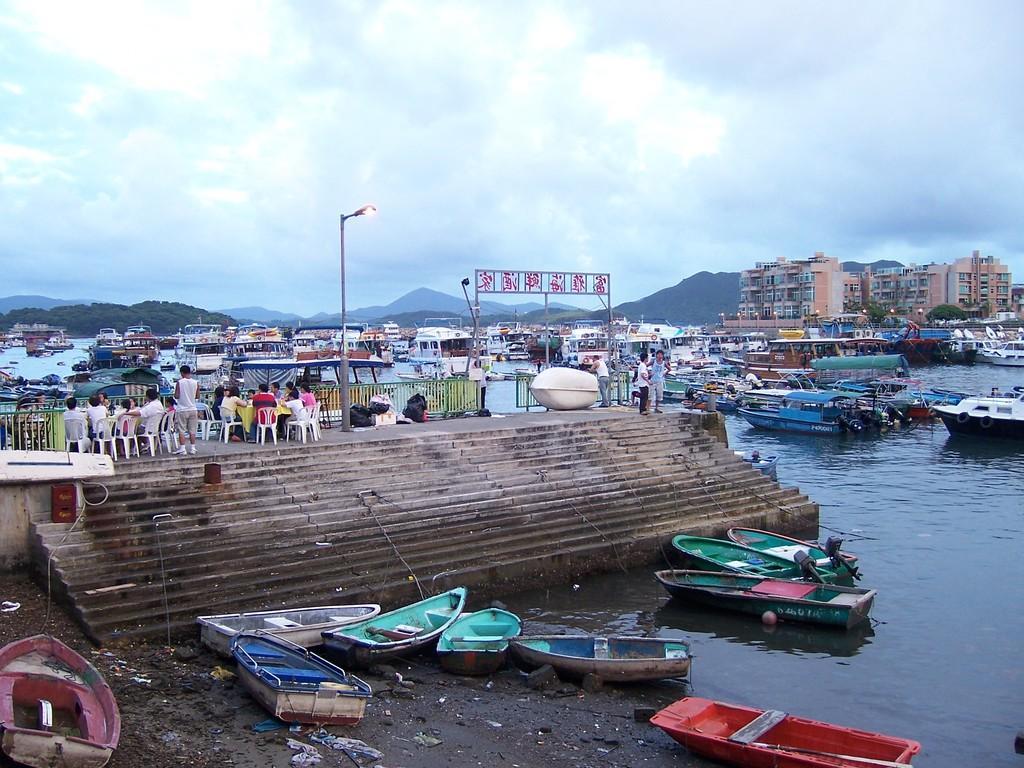How would you summarize this image in a sentence or two? In the center of the image we can see the sky, clouds, buildings, boats, trees, hills, lights, water, chairs, fences, one pole, staircase, few people are sitting, few people are standing and a few other objects. 